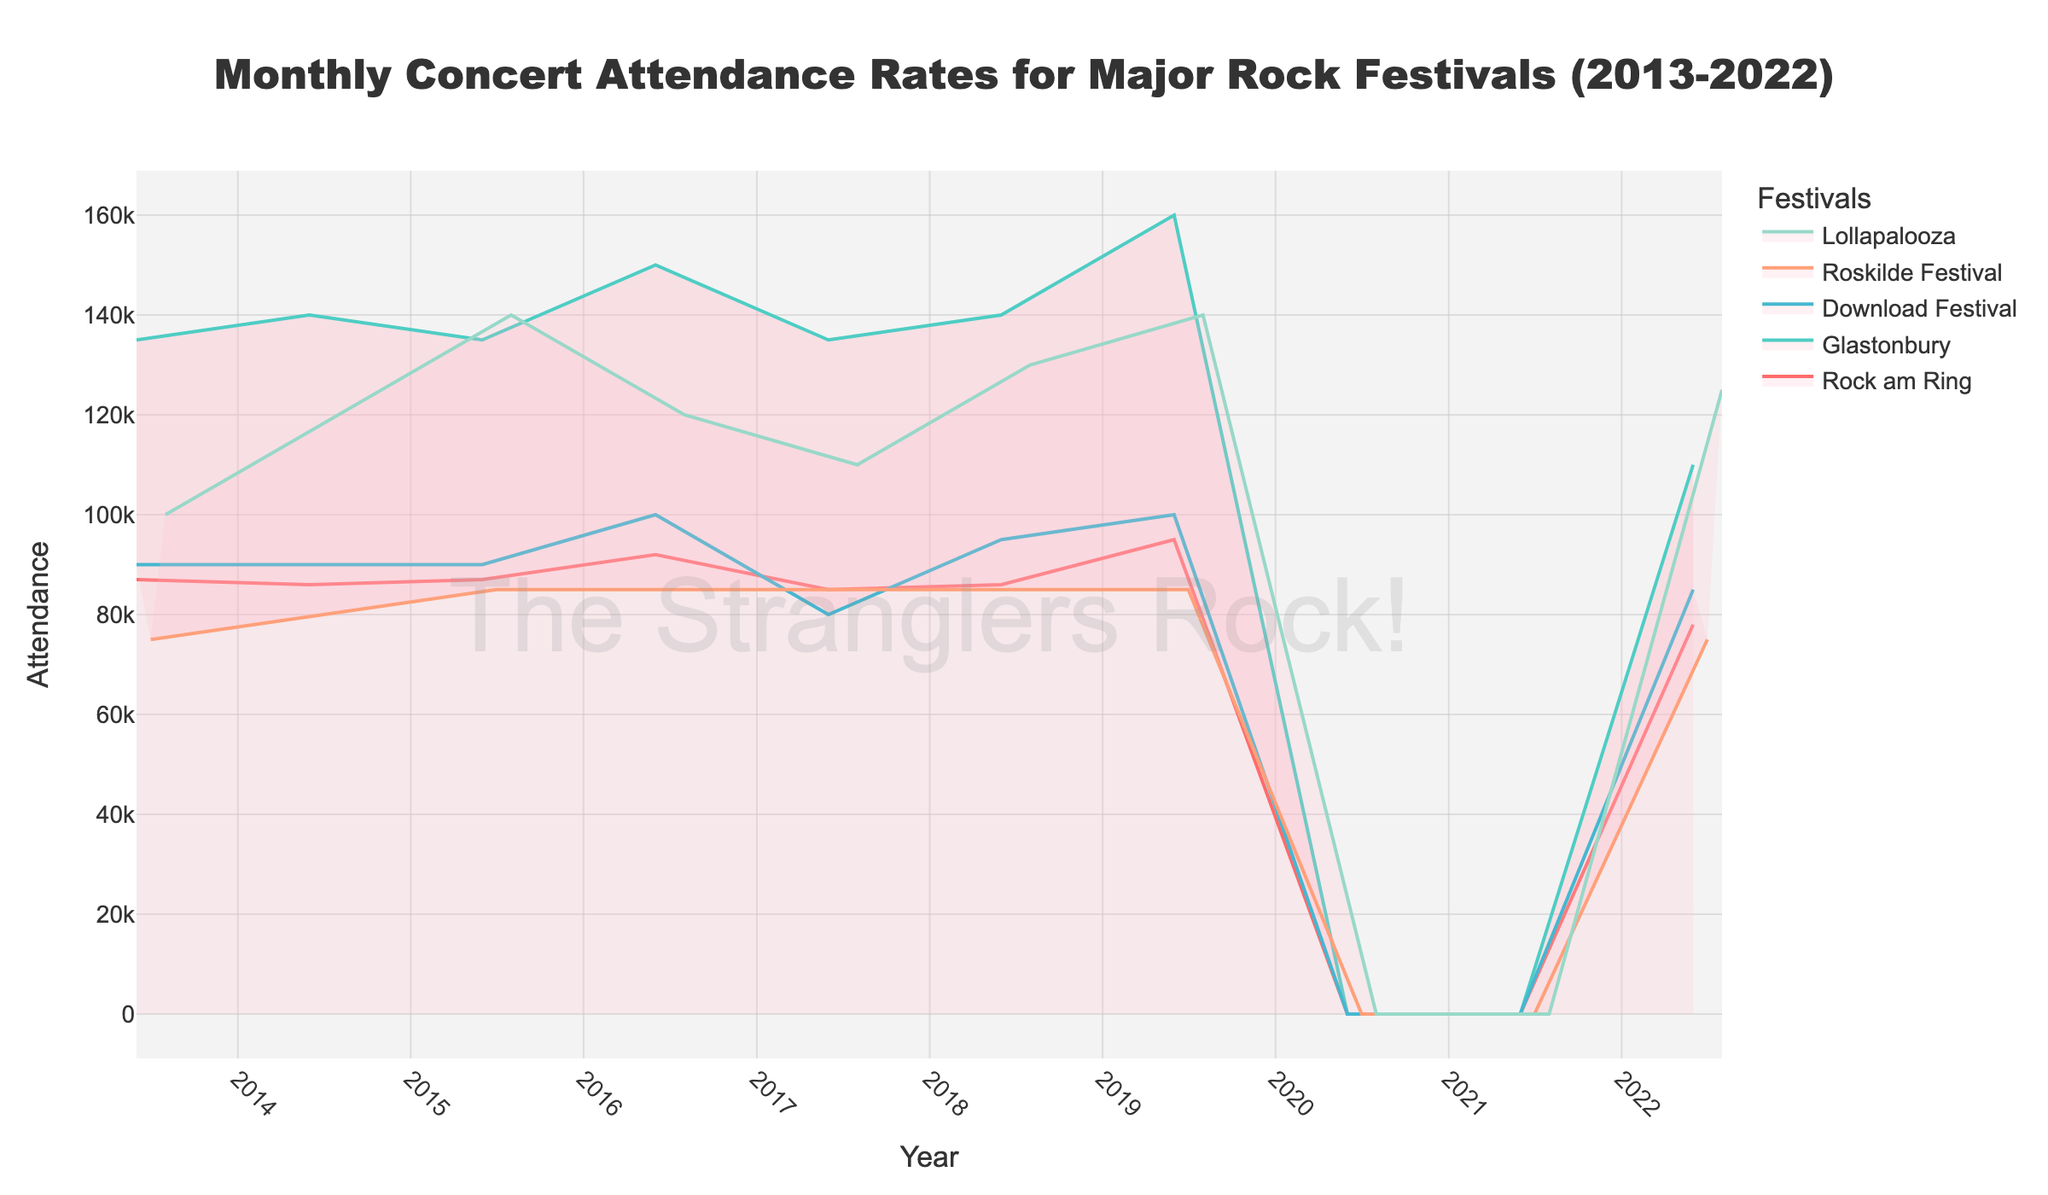What is the total concert attendance for Rock am Ring in 2013 and 2014? Look at the attendance values for Rock am Ring in 2013 (87,000) and 2014 (86,000). Sum these values: 87,000 + 86,000.
Answer: 173,000 Which festival had the highest attendance in June 2019? Identify the attendance values for each festival in June 2019: Rock am Ring (95,000), Glastonbury (160,000), Download Festival (100,000). Compare these values: 160,000 (Glastonbury) is the highest.
Answer: Glastonbury What does the fill color of each step area represent? The fill color below each line represents the area under the attendance curve for each respective festival. Each color corresponds to a specific festival.
Answer: Area under the attendance curve How did the COVID-19 pandemic affect attendance in 2020 and 2021 for these festivals? Review the attendance values for 2020 and 2021, noting that all festivals had zero attendance due to the pandemic.
Answer: Zero attendance for all festivals Which festival experienced the largest drop in attendance from 2019 to 2022? Calculate the drop in attendance for each festival from 2019 to 2022: 
Rock am Ring: 95,000 - 78,000 = 17,000; 
Glastonbury: 160,000 - 110,000 = 50,000; 
Download Festival: 100,000 - 85,000 = 15,000; 
Roskilde Festival: 85,000 - 75,000 = 10,000; 
Lollapalooza: 140,000 - 125,000 = 15,000. 
The largest drop is 50,000 for Glastonbury.
Answer: Glastonbury What is the trend of attendance for Roskilde Festival from 2013 to 2019? Examine the attendance values for Roskilde Festival from 2013 (75,000) to 2019 (85,000). The attendance increased from 75,000 to 80,000, then 85,000, and remained stable at 85,000 until 2019.
Answer: Increasing trend until stable at 85,000 How many festivals had zero attendance during the pandemic years? Identify each festival's attendance for the years 2020 and 2021; count how many were zero for both years: Rock am Ring, Glastonbury, Download Festival, Roskilde Festival, and Lollapalooza.
Answer: Five festivals Between which years did Lollapalooza see the largest increase in attendance? Compare the annual attendance for Lollapalooza: 
2013-2014 (20,000), 
2014-2015 (20,000), 
2015-2016 (-20,000), 
2016-2017 (-10,000), 
2017-2018 (20,000), 
2018-2019 (10,000). 
The largest increase was between 2014 to 2015 (20,000).
Answer: 2014 to 2015 Which festival has the steadiest attendance trend from 2013 to 2019? Examine each festival's attendance values from 2013 to 2019 for consistency. Rock am Ring shows fluctuations, 
Glastonbury fluctuates, 
Download Festival fluctuates but returns to a previous level, 
Roskilde Festival remains mostly steady around 85,000.
Answer: Roskilde Festival Which festival had a significant drop in attendance in 2022 compared to 2019? Compare 2019 and 2022 attendance values for each festival: 
Rock am Ring (95,000 to 78,000), 
Glastonbury (160,000 to 110,000), 
Download Festival (100,000 to 85,000), 
Roskilde Festival (85,000 to 75,000), 
Lollapalooza (140,000 to 125,000). 
Glastonbury had the most significant drop (50,000).
Answer: Glastonbury 